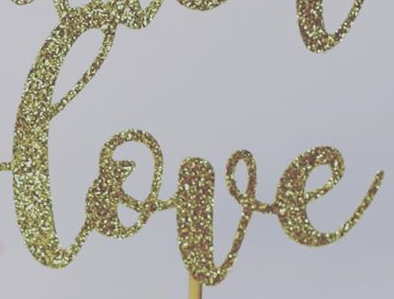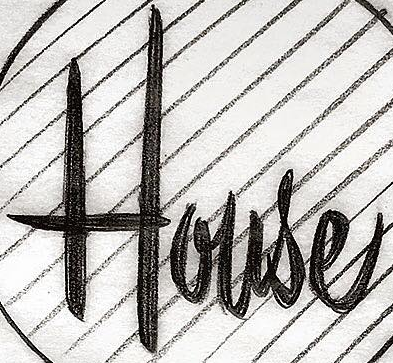What words are shown in these images in order, separated by a semicolon? love; House 